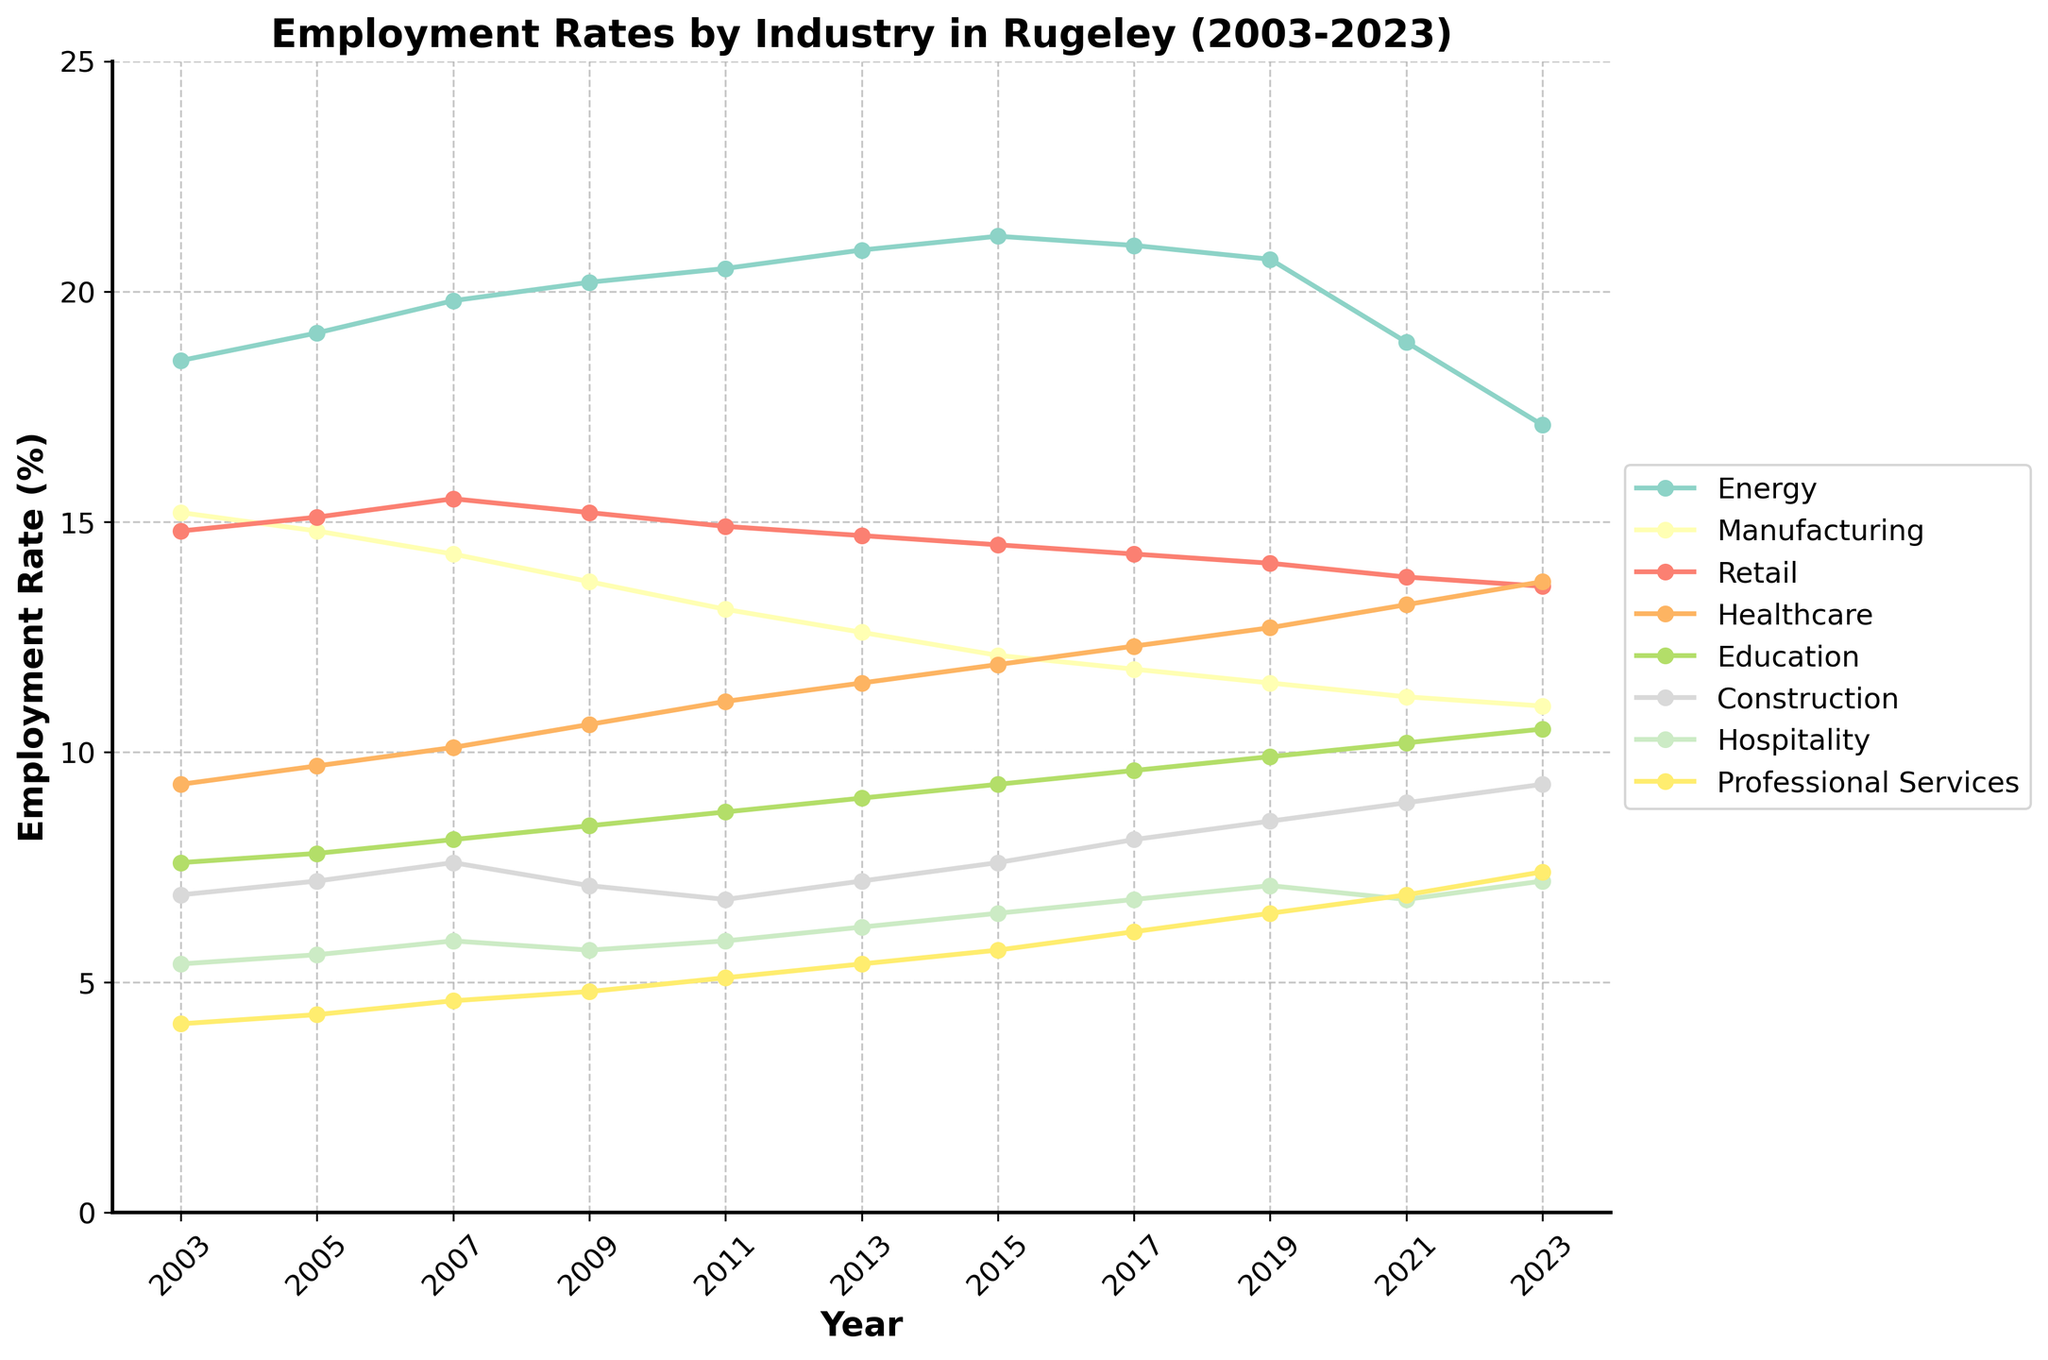What was the employment rate in the Healthcare sector in 2023? Look at the line representing the Healthcare sector in 2023 and read the value on the y-axis corresponding to that point.
Answer: 13.7 Which sector had the highest employment rate in 2007? Identify the highest point on the chart for the year 2007 and match it to the corresponding sector label.
Answer: Energy By how much did the employment rate in the Retail sector change from 2003 to 2023? Find the employment rate for Retail in 2003 and 2023, then subtract the 2003 value from the 2023 value.
Answer: -1.2 Which sector showed a continuous increase in employment rates from 2003 to 2017? Track each sector's line from 2003 to 2017 and identify which one has a consistent upward trend.
Answer: Healthcare Compare the employment rates of Education and Construction in 2023. Which one is greater and by how much? Find the 2023 values for both Education and Construction, then subtract the Construction value from the Education value to see which is larger and by how much.
Answer: Education by 1.2 Which sector had the most significant drop in employment rates from 2021 to 2023? Look at the employment rates for all sectors in 2021 and 2023 and determine which sector's line shows the steepest decline.
Answer: Energy What is the average employment rate in the Professional Services sector over the 20 years? Add the values of the Professional Services sector from all years and divide by the number of years (11).
Answer: 5.1 Compare the employment rates in the Manufacturing sector in 2003 and 2023. Did the rate increase or decrease, and by how much? Subtract the 2023 value from the 2003 value for Manufacturing to determine the change and its direction.
Answer: Decrease by 4.2 Which color represents the Education sector on the chart? Look for the line labeled Education in the chart legend and identify its color.
Answer: Light Blue (or specify the exact color visible from the plot) What was the employment rate trend in the Energy sector from 2015 to 2023? Observe the line representing the Energy sector between 2015 and 2023 and describe whether it trended upward, downward, or remained stable.
Answer: Downward 